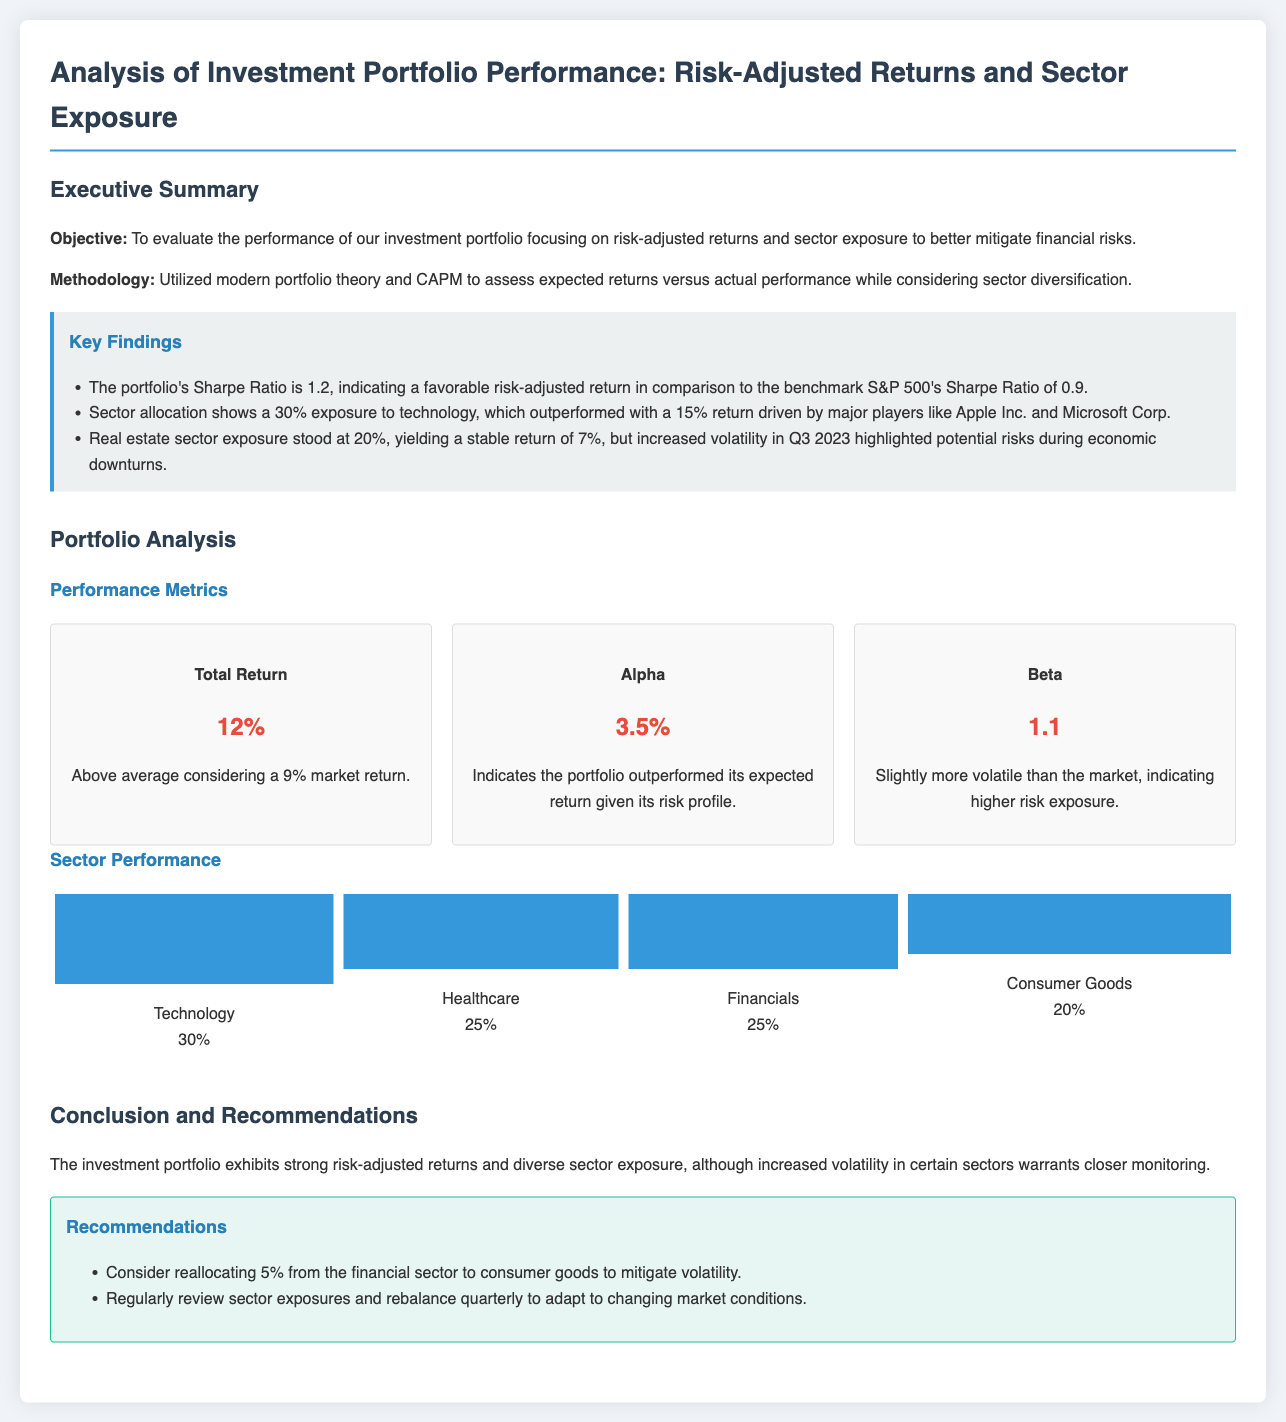What is the portfolio's Sharpe Ratio? The Sharpe Ratio is a measure of risk-adjusted return, and in this report, the portfolio's Sharpe Ratio is stated as 1.2.
Answer: 1.2 What was the total return of the portfolio? The total return is a key performance metric, and it is indicated in the document as 12%.
Answer: 12% What percentage of the portfolio is allocated to healthcare? The document specifies that 25% of the portfolio is allocated to the healthcare sector.
Answer: 25% What is the Alpha of the investment portfolio? The Alpha indicates the excess return of the portfolio compared to its expected return given its risk profile, which is provided as 3.5%.
Answer: 3.5% How should the portfolio be rebalanced according to the recommendations? The recommendations suggest rebalancing the portfolio quarterly to adapt to changing market conditions.
Answer: Quarterly What sector had the highest return, and what was that return? The technology sector outperformed with a return of 15%, as noted in the key findings.
Answer: 15% What was the Beta value reported for the portfolio? The Beta value is a measure of volatility, and the document reports it as 1.1.
Answer: 1.1 What is the stable return percentage from the real estate sector? The report indicates that the real estate sector yielded a stable return of 7%.
Answer: 7% What is the suggested action for mitigating volatility? It is recommended to consider reallocating 5% from the financial sector to consumer goods to mitigate volatility.
Answer: 5% 